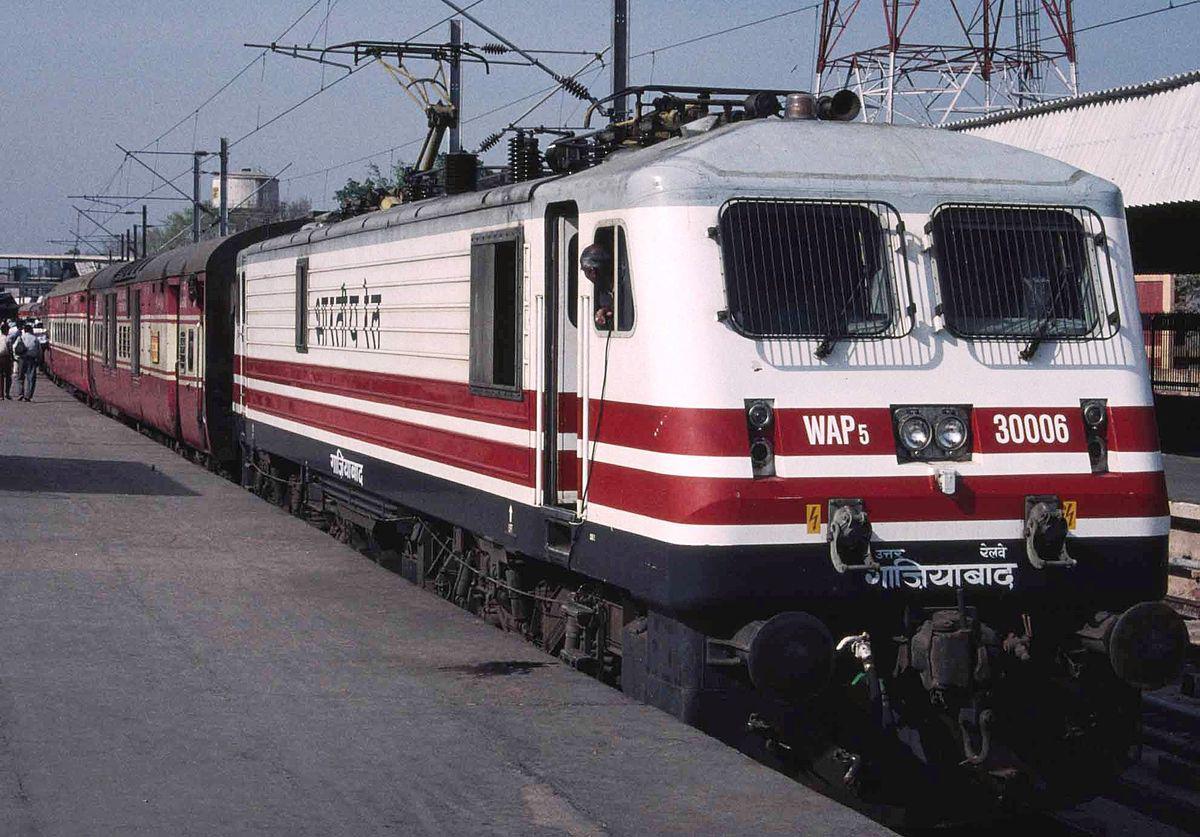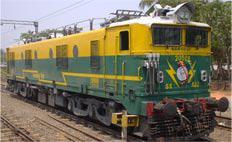The first image is the image on the left, the second image is the image on the right. Analyze the images presented: Is the assertion "The image on the right contains a green and yellow train." valid? Answer yes or no. Yes. 